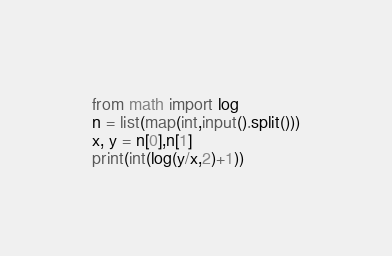Convert code to text. <code><loc_0><loc_0><loc_500><loc_500><_Python_>from math import log
n = list(map(int,input().split()))
x, y = n[0],n[1]
print(int(log(y/x,2)+1))</code> 